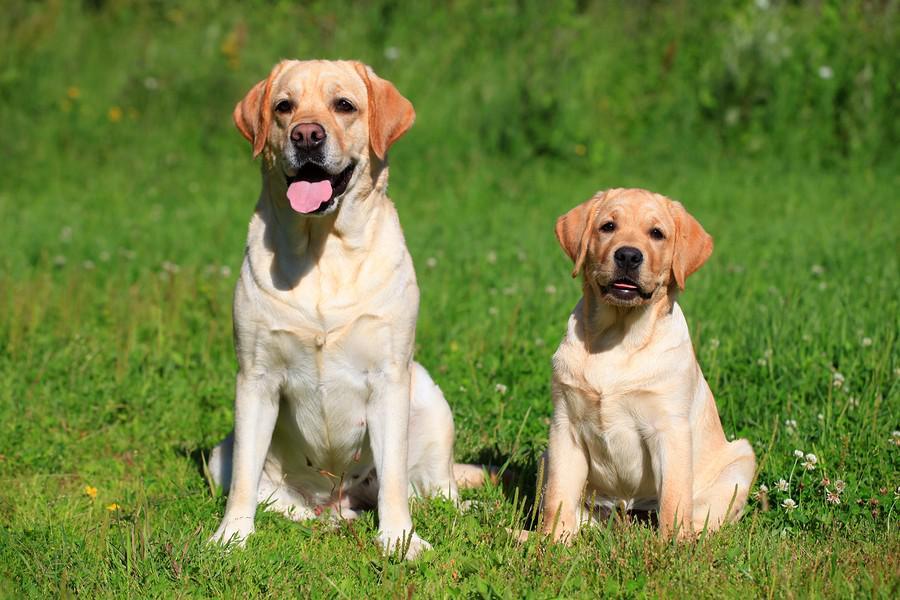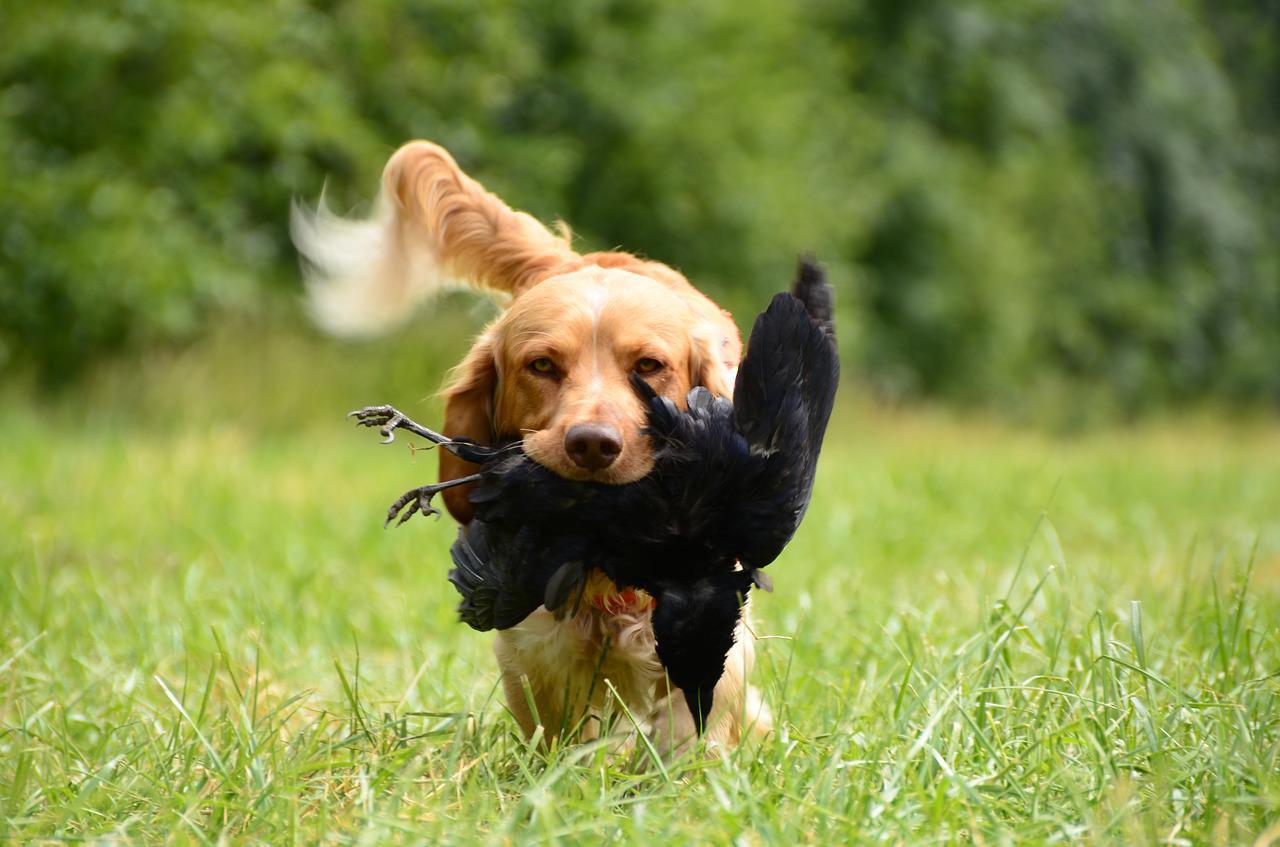The first image is the image on the left, the second image is the image on the right. For the images displayed, is the sentence "In at least one image, a dog is in a body of water while wearing a life jacket or flotation device of some kind" factually correct? Answer yes or no. No. The first image is the image on the left, the second image is the image on the right. Analyze the images presented: Is the assertion "The left image contains one dog that is black." valid? Answer yes or no. No. 